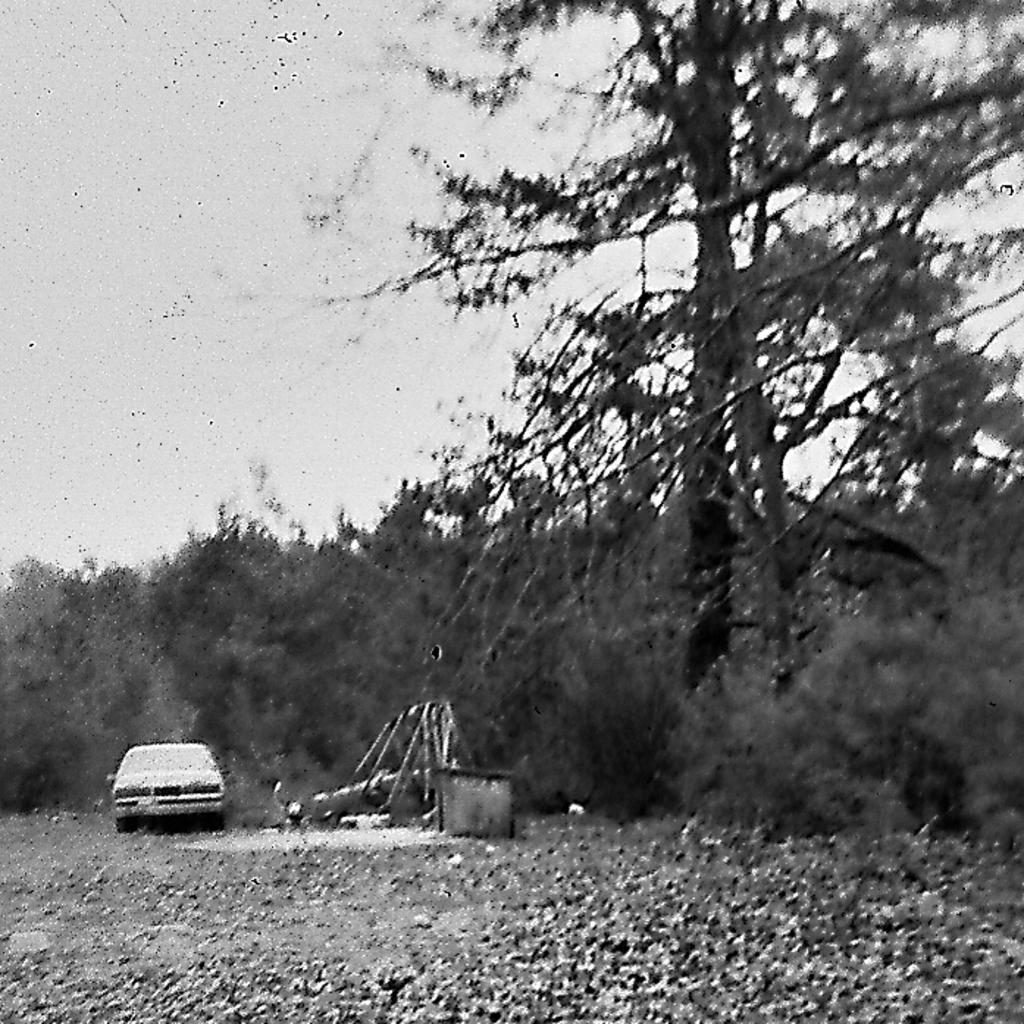What type of vegetation can be seen in the image? There are trees in the image. What is the main subject in the middle of the image? There is a car in the middle of the image. What can be seen in the background of the image? The sky is visible in the background of the image. Can you see a rabbit flying in the sky in the image? There is no rabbit present in the image, and it is not flying in the sky. How many trees are pushing the car in the image? There are no trees pushing the car in the image; the trees are stationary. 